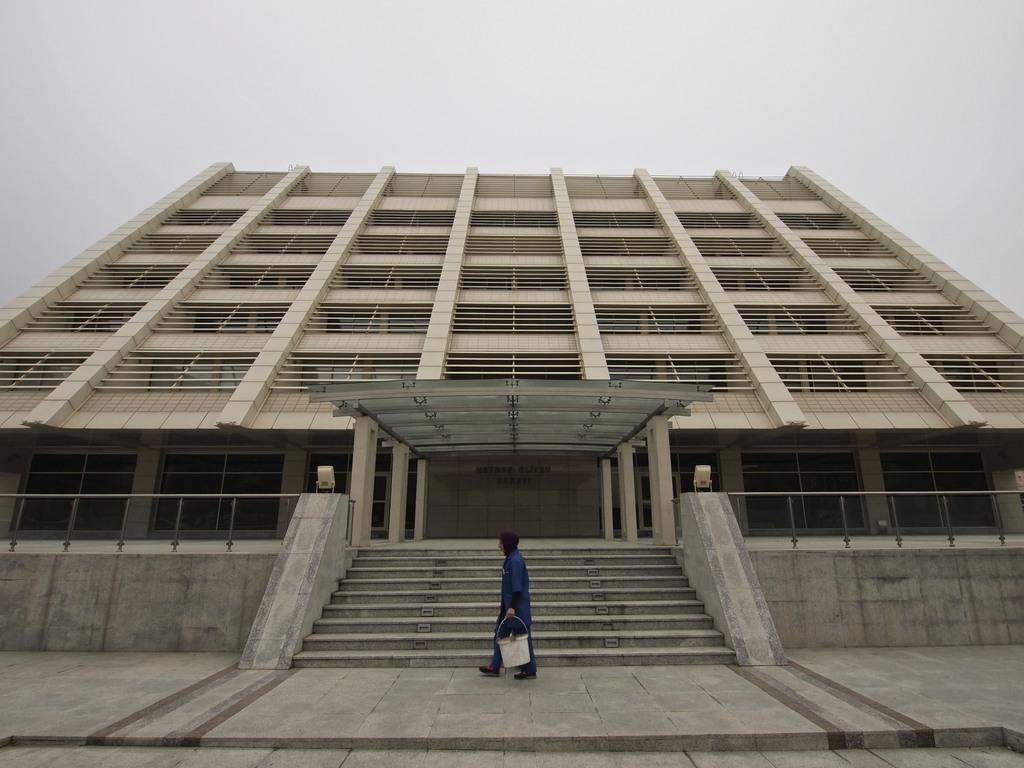Can you describe this image briefly? In the image,there is a big building and in front of the building a person is walking beside the steps by holding a bucket in the hand,In the background there is a sky. 